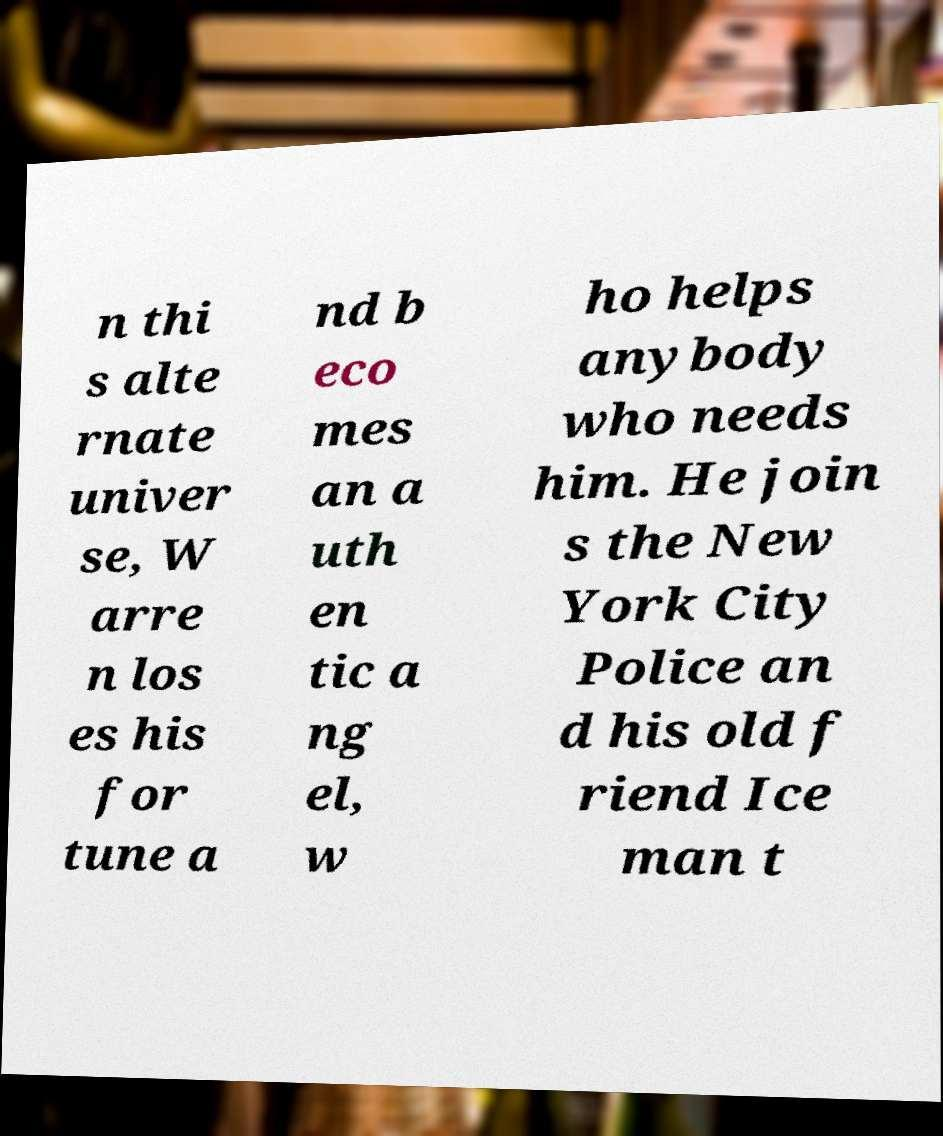Could you assist in decoding the text presented in this image and type it out clearly? n thi s alte rnate univer se, W arre n los es his for tune a nd b eco mes an a uth en tic a ng el, w ho helps anybody who needs him. He join s the New York City Police an d his old f riend Ice man t 